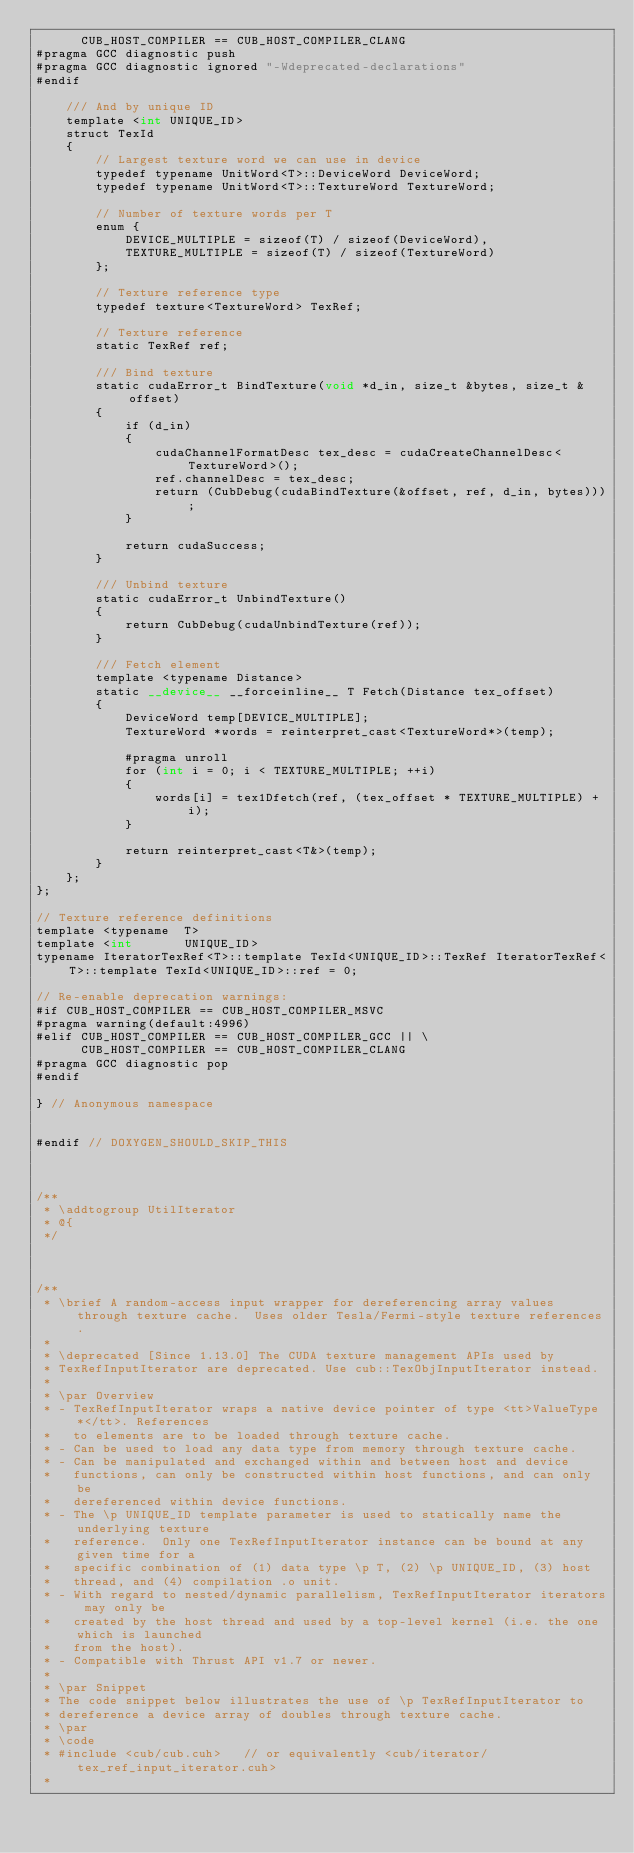Convert code to text. <code><loc_0><loc_0><loc_500><loc_500><_Cuda_>      CUB_HOST_COMPILER == CUB_HOST_COMPILER_CLANG
#pragma GCC diagnostic push
#pragma GCC diagnostic ignored "-Wdeprecated-declarations"
#endif

    /// And by unique ID
    template <int UNIQUE_ID>
    struct TexId
    {
        // Largest texture word we can use in device
        typedef typename UnitWord<T>::DeviceWord DeviceWord;
        typedef typename UnitWord<T>::TextureWord TextureWord;

        // Number of texture words per T
        enum {
            DEVICE_MULTIPLE = sizeof(T) / sizeof(DeviceWord),
            TEXTURE_MULTIPLE = sizeof(T) / sizeof(TextureWord)
        };

        // Texture reference type
        typedef texture<TextureWord> TexRef;

        // Texture reference
        static TexRef ref;

        /// Bind texture
        static cudaError_t BindTexture(void *d_in, size_t &bytes, size_t &offset)
        {
            if (d_in)
            {
                cudaChannelFormatDesc tex_desc = cudaCreateChannelDesc<TextureWord>();
                ref.channelDesc = tex_desc;
                return (CubDebug(cudaBindTexture(&offset, ref, d_in, bytes)));
            }

            return cudaSuccess;
        }

        /// Unbind texture
        static cudaError_t UnbindTexture()
        {
            return CubDebug(cudaUnbindTexture(ref));
        }

        /// Fetch element
        template <typename Distance>
        static __device__ __forceinline__ T Fetch(Distance tex_offset)
        {
            DeviceWord temp[DEVICE_MULTIPLE];
            TextureWord *words = reinterpret_cast<TextureWord*>(temp);

            #pragma unroll
            for (int i = 0; i < TEXTURE_MULTIPLE; ++i)
            {
                words[i] = tex1Dfetch(ref, (tex_offset * TEXTURE_MULTIPLE) + i);
            }

            return reinterpret_cast<T&>(temp);
        }
    };
};

// Texture reference definitions
template <typename  T>
template <int       UNIQUE_ID>
typename IteratorTexRef<T>::template TexId<UNIQUE_ID>::TexRef IteratorTexRef<T>::template TexId<UNIQUE_ID>::ref = 0;

// Re-enable deprecation warnings:
#if CUB_HOST_COMPILER == CUB_HOST_COMPILER_MSVC
#pragma warning(default:4996)
#elif CUB_HOST_COMPILER == CUB_HOST_COMPILER_GCC || \
      CUB_HOST_COMPILER == CUB_HOST_COMPILER_CLANG
#pragma GCC diagnostic pop
#endif

} // Anonymous namespace


#endif // DOXYGEN_SHOULD_SKIP_THIS



/**
 * \addtogroup UtilIterator
 * @{
 */



/**
 * \brief A random-access input wrapper for dereferencing array values through texture cache.  Uses older Tesla/Fermi-style texture references.
 *
 * \deprecated [Since 1.13.0] The CUDA texture management APIs used by
 * TexRefInputIterator are deprecated. Use cub::TexObjInputIterator instead.
 *
 * \par Overview
 * - TexRefInputIterator wraps a native device pointer of type <tt>ValueType*</tt>. References
 *   to elements are to be loaded through texture cache.
 * - Can be used to load any data type from memory through texture cache.
 * - Can be manipulated and exchanged within and between host and device
 *   functions, can only be constructed within host functions, and can only be
 *   dereferenced within device functions.
 * - The \p UNIQUE_ID template parameter is used to statically name the underlying texture
 *   reference.  Only one TexRefInputIterator instance can be bound at any given time for a
 *   specific combination of (1) data type \p T, (2) \p UNIQUE_ID, (3) host
 *   thread, and (4) compilation .o unit.
 * - With regard to nested/dynamic parallelism, TexRefInputIterator iterators may only be
 *   created by the host thread and used by a top-level kernel (i.e. the one which is launched
 *   from the host).
 * - Compatible with Thrust API v1.7 or newer.
 *
 * \par Snippet
 * The code snippet below illustrates the use of \p TexRefInputIterator to
 * dereference a device array of doubles through texture cache.
 * \par
 * \code
 * #include <cub/cub.cuh>   // or equivalently <cub/iterator/tex_ref_input_iterator.cuh>
 *</code> 